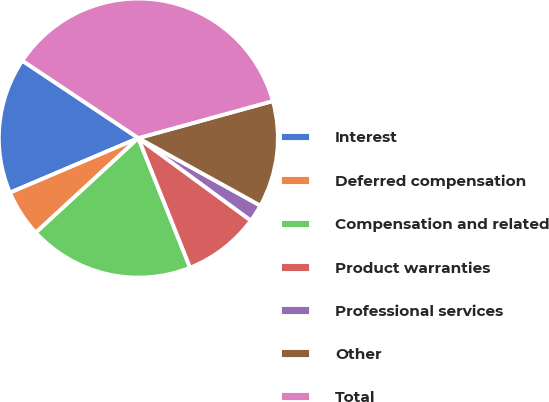Convert chart to OTSL. <chart><loc_0><loc_0><loc_500><loc_500><pie_chart><fcel>Interest<fcel>Deferred compensation<fcel>Compensation and related<fcel>Product warranties<fcel>Professional services<fcel>Other<fcel>Total<nl><fcel>15.76%<fcel>5.46%<fcel>19.19%<fcel>8.89%<fcel>2.02%<fcel>12.32%<fcel>36.36%<nl></chart> 